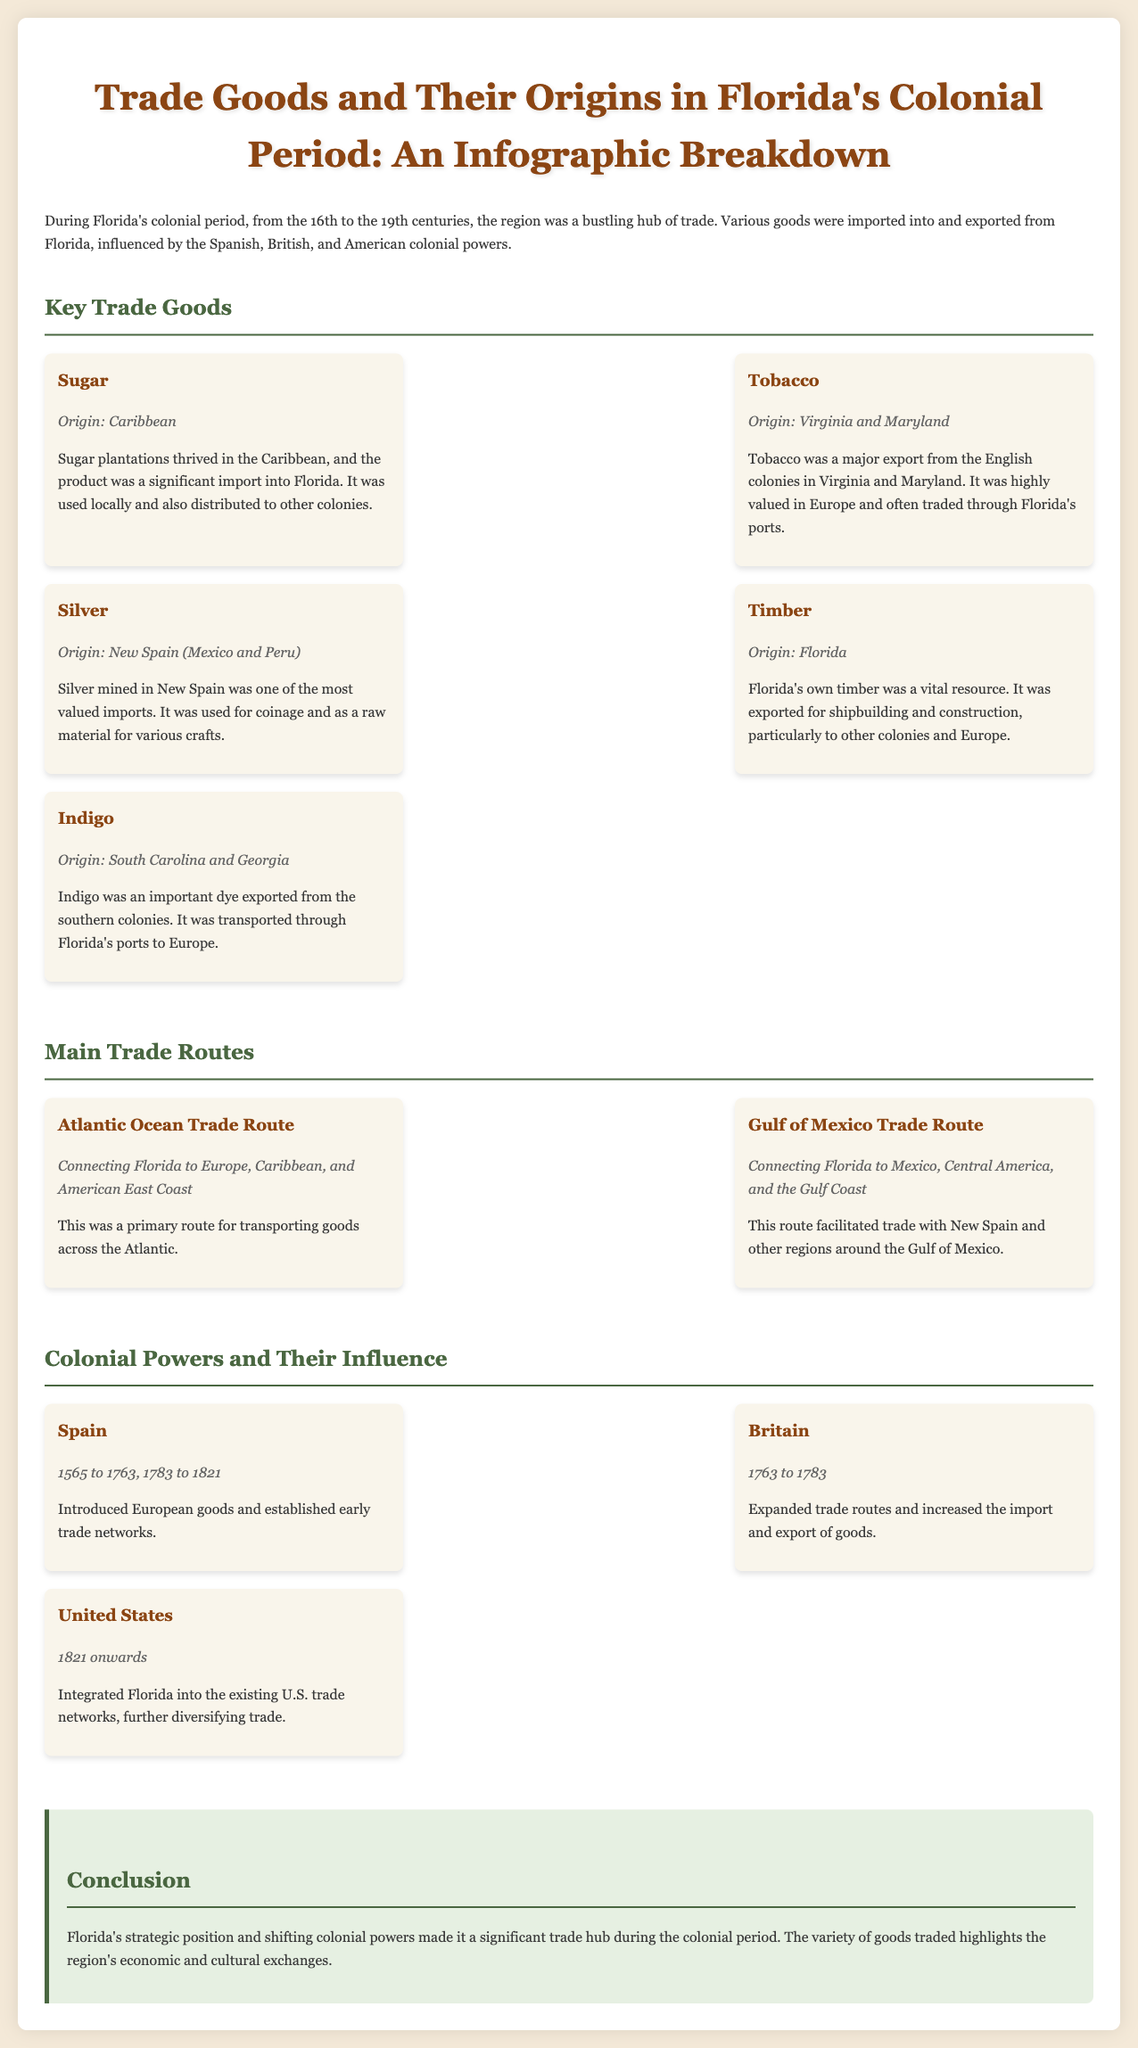What were the origins of sugar? The origin of sugar is mentioned in the trade goods section, specifically noted as coming from the Caribbean.
Answer: Caribbean Which colonial power controlled Florida from 1763 to 1783? The document states that Britain was the colonial power in control during this specific period.
Answer: Britain What was a major export from Virginia and Maryland? Tobacco is identified as a major export from the English colonies in Virginia and Maryland in the document.
Answer: Tobacco What trade route connected Florida to Europe? The document lists the Atlantic Ocean Trade Route as the key connection of Florida to Europe.
Answer: Atlantic Ocean Trade Route Which good was primarily exported from Florida for shipbuilding? Timber is highlighted in the infographic as a vital resource exported for shipbuilding.
Answer: Timber How long did Spain influence Florida's trade networks? The document states that Spain influenced Florida’s trade networks from 1565 to 1763 and again from 1783 to 1821.
Answer: 1565 to 1763, 1783 to 1821 What was the origin of indigo? The origin of indigo is stated as South Carolina and Georgia in the document.
Answer: South Carolina and Georgia What was one use of silver imported from New Spain? The document mentions that silver was used for coinage and crafts, indicating its significance.
Answer: Coinage What was the purpose of the Gulf of Mexico Trade Route? The Gulf of Mexico Trade Route is described as a facilitator of trade with New Spain and regions around the Gulf.
Answer: Trade with New Spain 